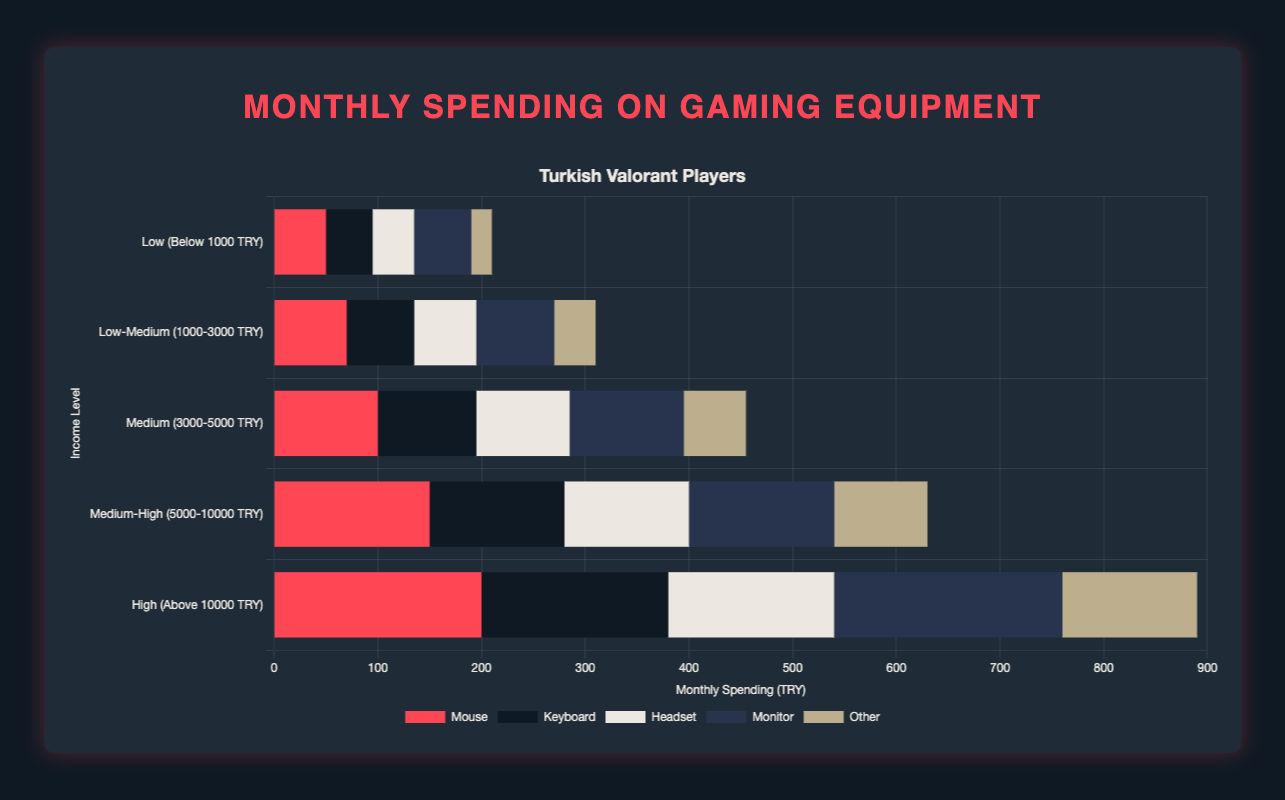Which category of equipment has the highest average spending across all income levels? To find this, sum the spending of each category across all income levels and divide by the number of income levels. For instance, for "Mouse", the sum is 50 + 70 + 100 + 150 + 200 = 570. The average would be 570 / 5 = 114. Repeating this for each category shows "Monitor" has the highest average spending with (55 + 75 + 110 + 140 + 220) / 5 = 120.
Answer: Monitor What’s the total spending on "Other" equipment by Medium-High and High income levels? Sum the spending on "Other" for the Medium-High and High income levels. Medium-High: 90, High: 130. Therefore, 90 + 130 = 220.
Answer: 220 Which income level has the highest total spending on gaming equipment? Add the expenditures for all equipment categories for each income level. For example, for "Low": (50 + 45 + 40 + 55 + 20) = 210. The highest is for "High": (200 + 180 + 160 + 220 + 130) = 890.
Answer: High How does the spending on Mouse for Medium income level compare with Low-Medium income level? Compare the values: Medium: 100, Low-Medium: 70. So, Medium spending is higher than Low-Medium spending by 100 - 70 = 30.
Answer: Medium is higher by 30 Which income level spends the most on Headsets? Observing the "Headset" data across all levels, the highest spending is with the "High" income level: 160.
Answer: High What’s the difference in spending on Monitors between Low and Medium-High income levels? Subtract the spending on Monitors for Low from Medium-High. Medium-High: 140, Low: 55. The difference is 140 - 55 = 85.
Answer: 85 In which category does the Low income level spend the least? Compare the spending values of the Low income level across all equipment categories: Mouse: 50, Keyboard: 45, Headset: 40, Monitor: 55, Other: 20. The least spending is on "Other" with 20.
Answer: Other If combined spending on Keyboard and Monitor for Low-Medium income level equals a certain value, what is it? Add the spending on Keyboard and Monitor for Low-Medium income level. Keyboard: 65, Monitor: 75. Therefore, 65 + 75 = 140.
Answer: 140 Rank the income levels from highest to lowest based on their spending on Keyboards. Arrange the Keyboard spending data from highest to lowest: High: 180, Medium-High: 130, Medium: 95, Low-Medium: 65, Low: 45.
Answer: High, Medium-High, Medium, Low-Medium, Low 